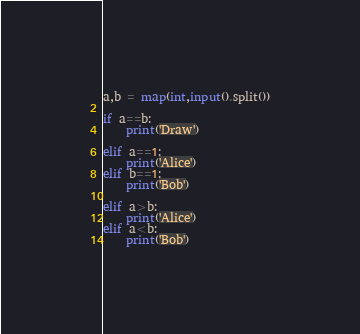<code> <loc_0><loc_0><loc_500><loc_500><_Python_>a,b = map(int,input().split())

if a==b:
    print('Draw')

elif a==1:
    print('Alice')
elif b==1:
    print('Bob')

elif a>b:
    print('Alice')
elif a<b:
    print('Bob')
</code> 